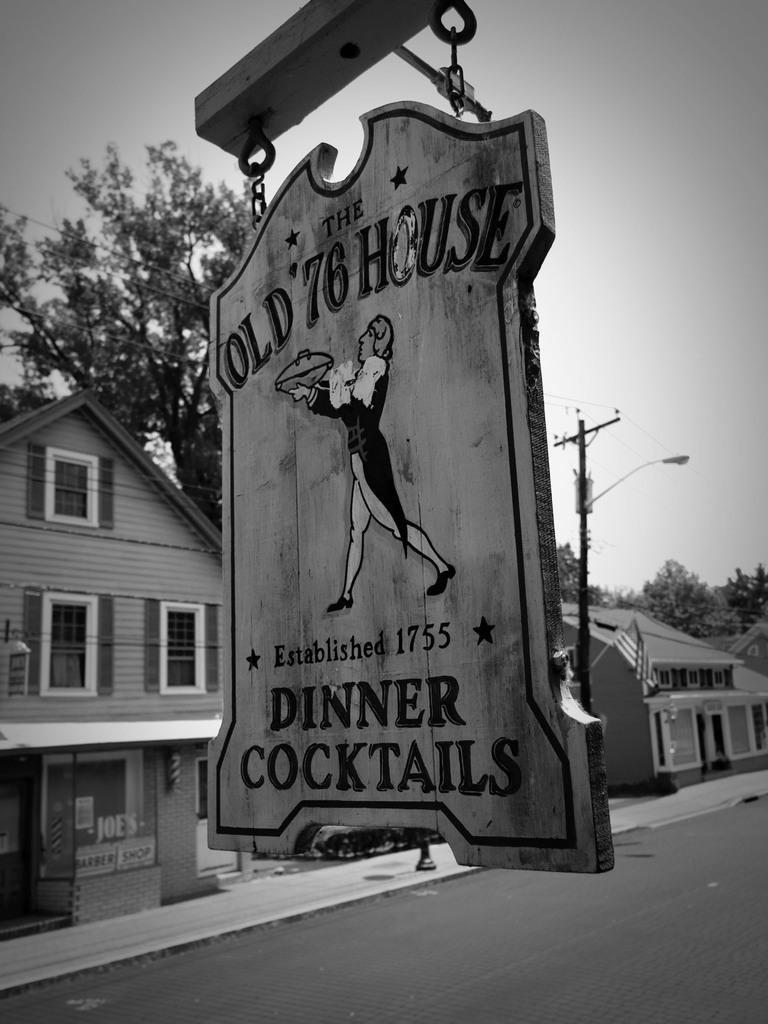What is the main object in the image? There is a sign board in the image. What type of structures can be seen in the image? There are homes in the image. What is the primary pathway visible in the image? There is a road in the image. What type of vegetation is present in the image? There is a tree in the image. What is the tall, vertical object in the image? There is a pole in the image. What is visible at the top of the image? The sky is visible at the top of the image. How many toes can be seen on the frog in the image? There is no frog present in the image, so the number of toes cannot be determined. 